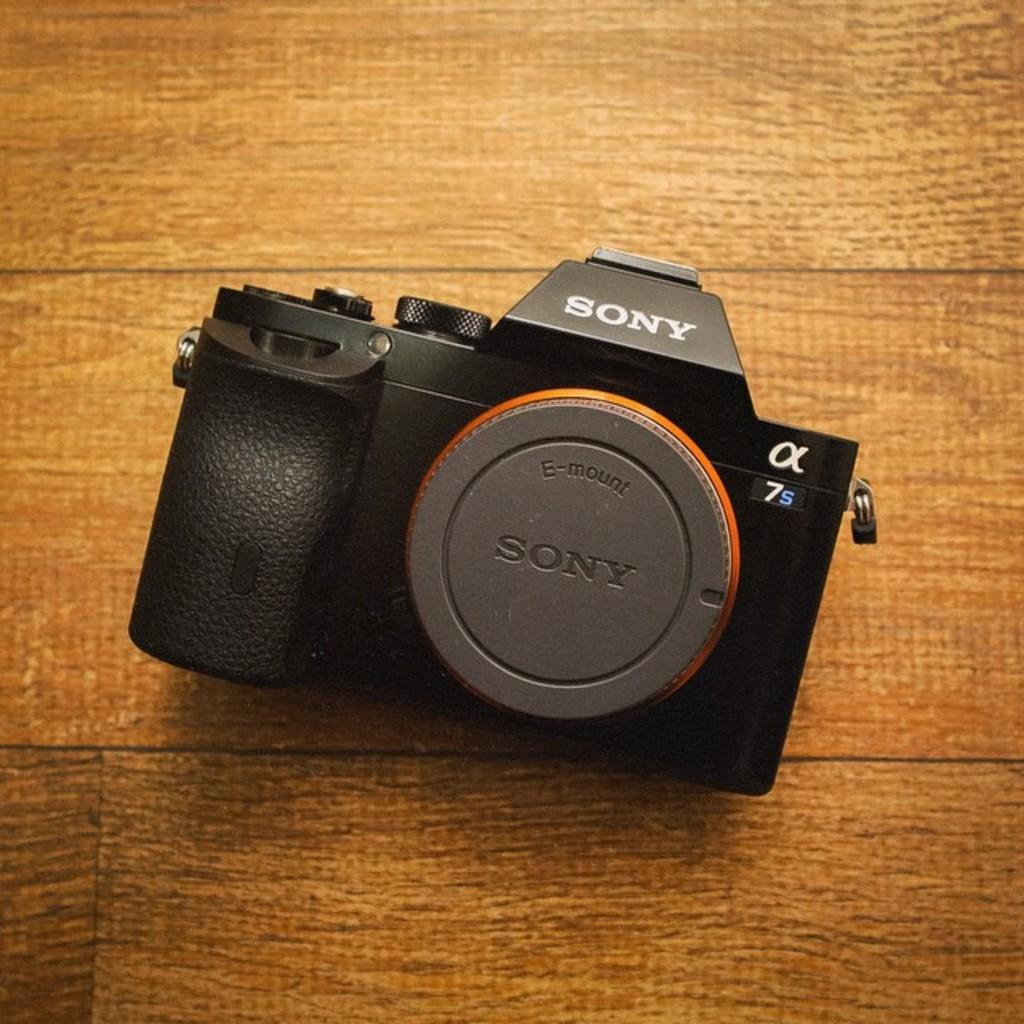<image>
Render a clear and concise summary of the photo. a sony camera has a lens cap on it and is laying on the table 